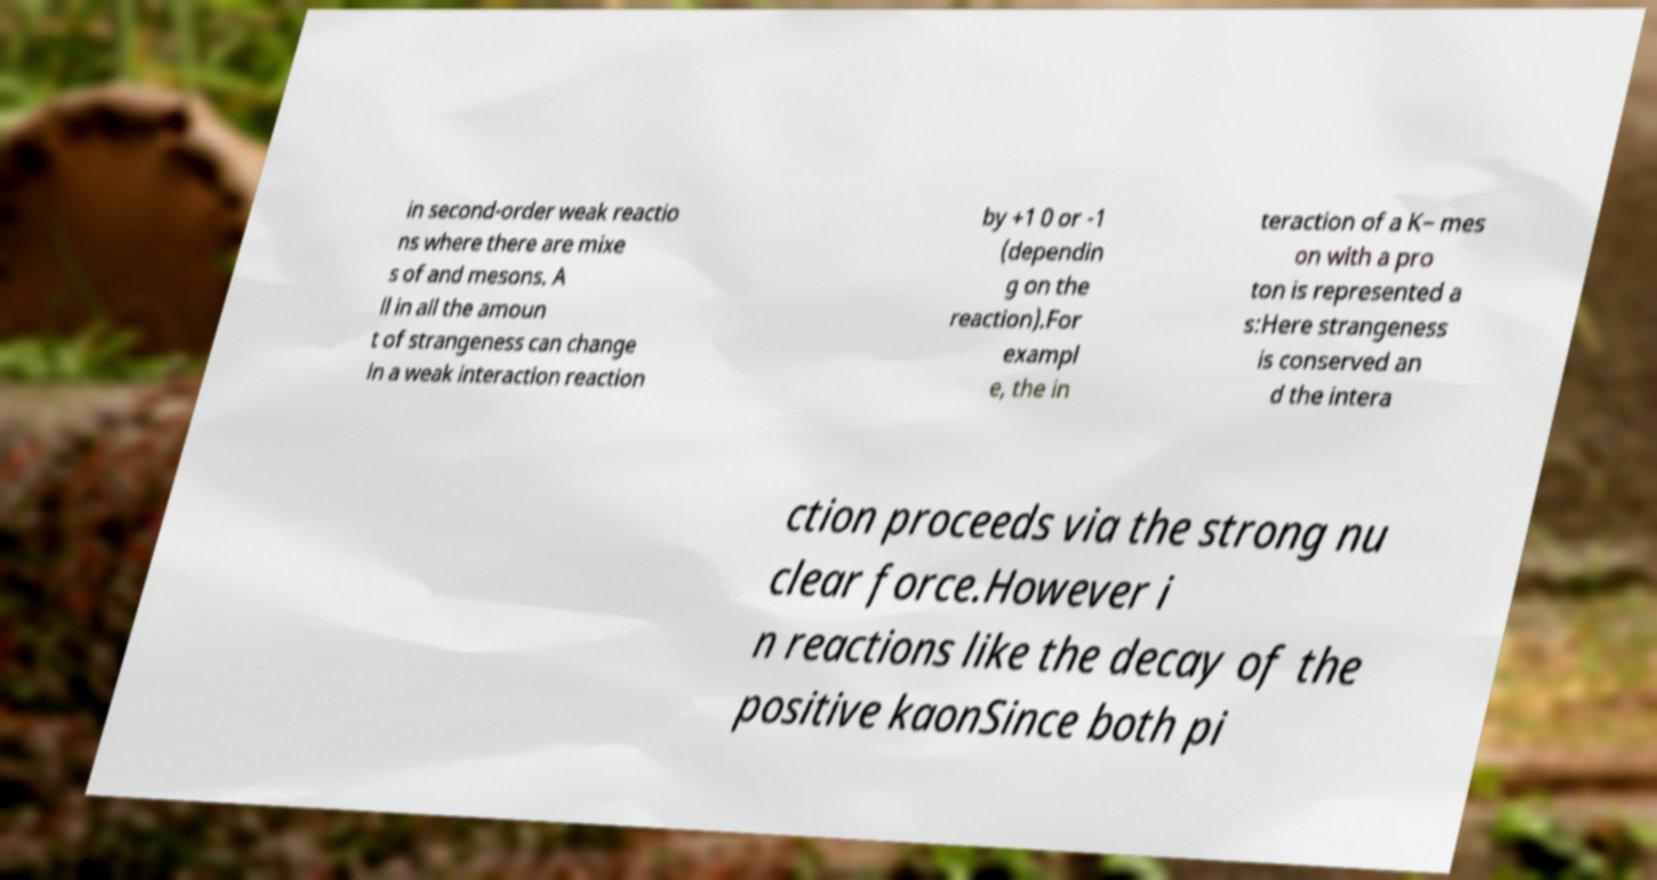For documentation purposes, I need the text within this image transcribed. Could you provide that? in second-order weak reactio ns where there are mixe s of and mesons. A ll in all the amoun t of strangeness can change in a weak interaction reaction by +1 0 or -1 (dependin g on the reaction).For exampl e, the in teraction of a K− mes on with a pro ton is represented a s:Here strangeness is conserved an d the intera ction proceeds via the strong nu clear force.However i n reactions like the decay of the positive kaonSince both pi 